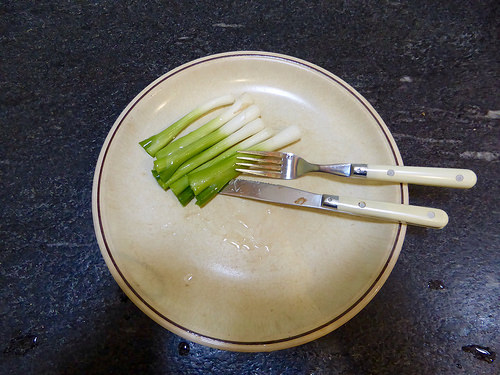<image>
Is the fork behind the plate? No. The fork is not behind the plate. From this viewpoint, the fork appears to be positioned elsewhere in the scene. Is there a knife next to the plate? No. The knife is not positioned next to the plate. They are located in different areas of the scene. 